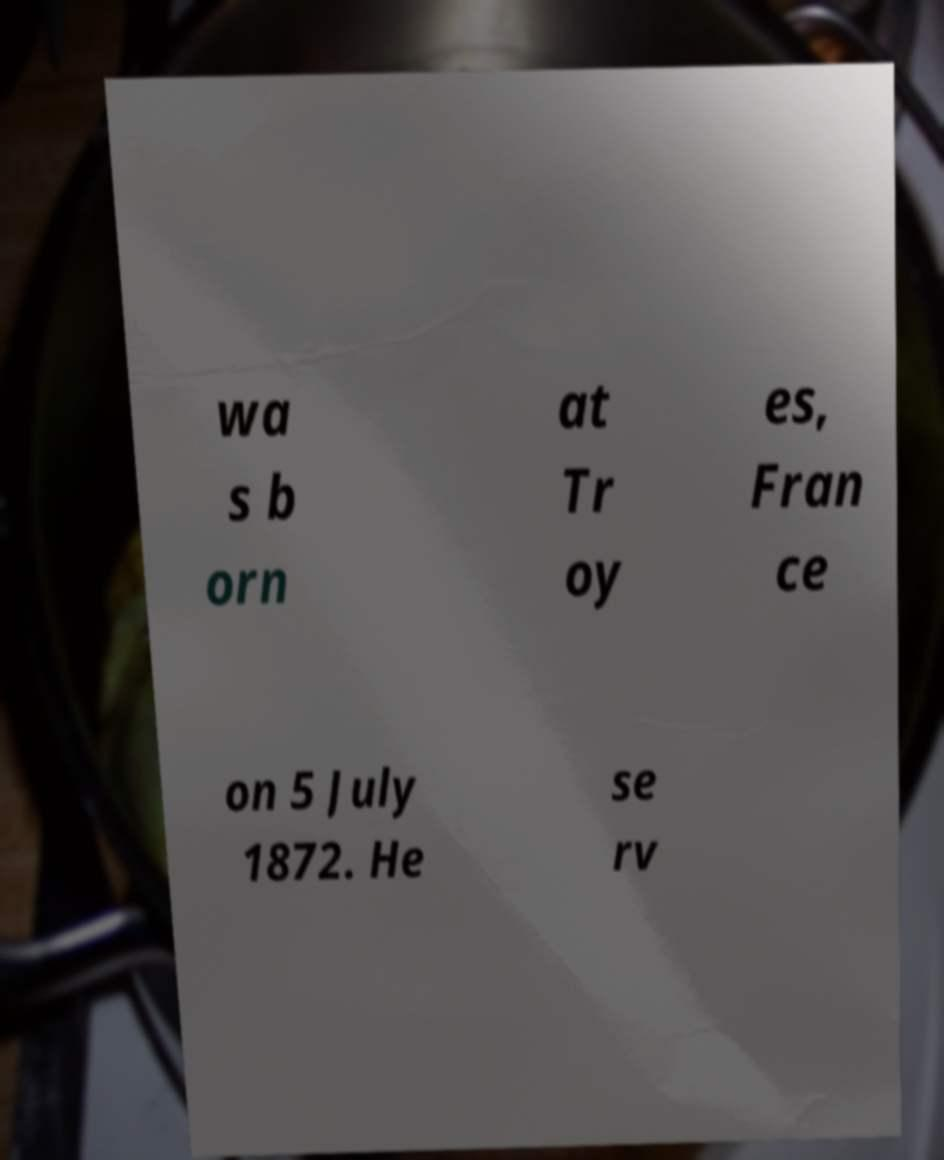Can you accurately transcribe the text from the provided image for me? wa s b orn at Tr oy es, Fran ce on 5 July 1872. He se rv 